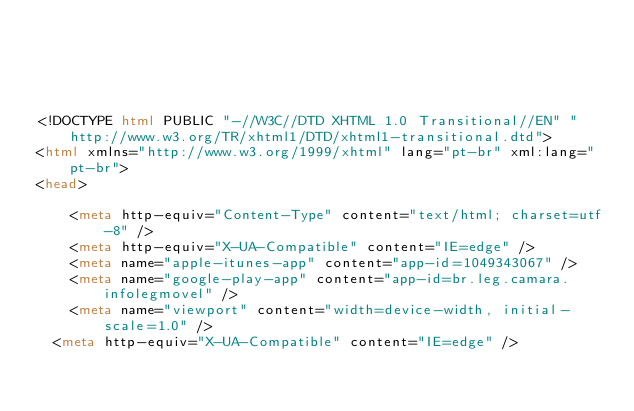Convert code to text. <code><loc_0><loc_0><loc_500><loc_500><_HTML_>




<!DOCTYPE html PUBLIC "-//W3C//DTD XHTML 1.0 Transitional//EN" "http://www.w3.org/TR/xhtml1/DTD/xhtml1-transitional.dtd">
<html xmlns="http://www.w3.org/1999/xhtml" lang="pt-br" xml:lang="pt-br">
<head>
	    
    <meta http-equiv="Content-Type" content="text/html; charset=utf-8" />
    <meta http-equiv="X-UA-Compatible" content="IE=edge" />
    <meta name="apple-itunes-app" content="app-id=1049343067" />
    <meta name="google-play-app" content="app-id=br.leg.camara.infolegmovel" />
    <meta name="viewport" content="width=device-width, initial-scale=1.0" />
	<meta http-equiv="X-UA-Compatible" content="IE=edge" /> 
    </code> 